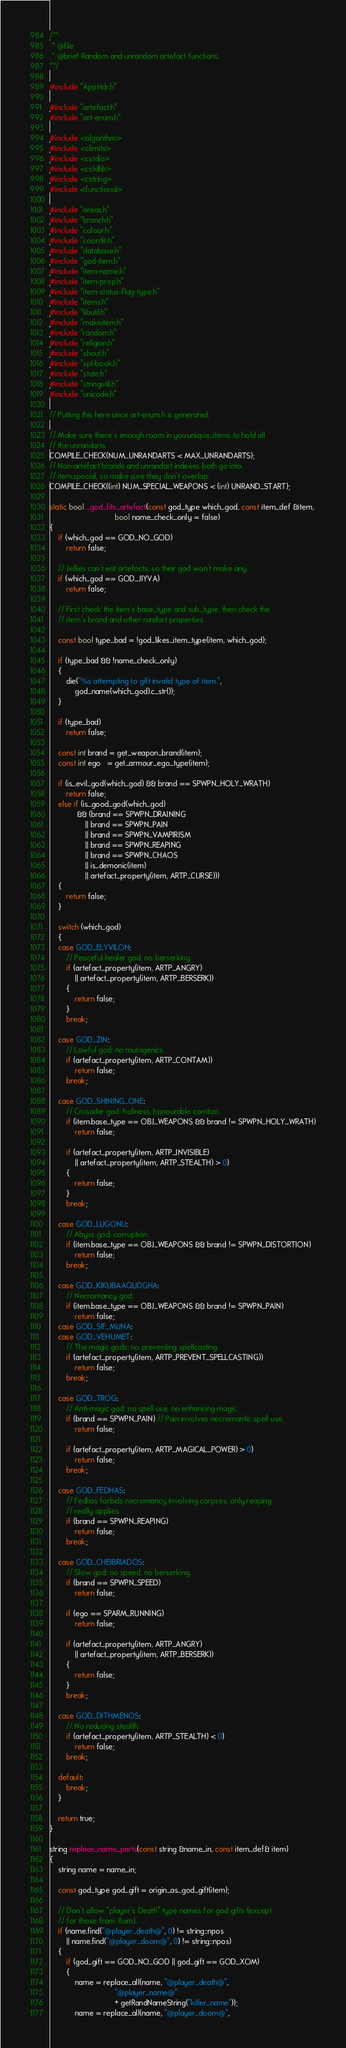Convert code to text. <code><loc_0><loc_0><loc_500><loc_500><_C++_>/**
 * @file
 * @brief Random and unrandom artefact functions.
**/

#include "AppHdr.h"

#include "artefact.h"
#include "art-enum.h"

#include <algorithm>
#include <climits>
#include <cstdio>
#include <cstdlib>
#include <cstring>
#include <functional>

#include "areas.h"
#include "branch.h"
#include "colour.h"
#include "coordit.h"
#include "database.h"
#include "god-item.h"
#include "item-name.h"
#include "item-prop.h"
#include "item-status-flag-type.h"
#include "items.h"
#include "libutil.h"
#include "makeitem.h"
#include "random.h"
#include "religion.h"
#include "shout.h"
#include "spl-book.h"
#include "state.h"
#include "stringutil.h"
#include "unicode.h"

// Putting this here since art-enum.h is generated.

// Make sure there's enough room in you.unique_items to hold all
// the unrandarts.
COMPILE_CHECK(NUM_UNRANDARTS < MAX_UNRANDARTS);
// Non-artefact brands and unrandart indexes both go into
// item.special, so make sure they don't overlap.
COMPILE_CHECK((int) NUM_SPECIAL_WEAPONS < (int) UNRAND_START);

static bool _god_fits_artefact(const god_type which_god, const item_def &item,
                               bool name_check_only = false)
{
    if (which_god == GOD_NO_GOD)
        return false;

    // Jellies can't eat artefacts, so their god won't make any.
    if (which_god == GOD_JIYVA)
        return false;

    // First check the item's base_type and sub_type, then check the
    // item's brand and other randart properties.

    const bool type_bad = !god_likes_item_type(item, which_god);

    if (type_bad && !name_check_only)
    {
        die("%s attempting to gift invalid type of item.",
            god_name(which_god).c_str());
    }

    if (type_bad)
        return false;

    const int brand = get_weapon_brand(item);
    const int ego   = get_armour_ego_type(item);

    if (is_evil_god(which_god) && brand == SPWPN_HOLY_WRATH)
        return false;
    else if (is_good_god(which_god)
             && (brand == SPWPN_DRAINING
                 || brand == SPWPN_PAIN
                 || brand == SPWPN_VAMPIRISM
                 || brand == SPWPN_REAPING
                 || brand == SPWPN_CHAOS
                 || is_demonic(item)
                 || artefact_property(item, ARTP_CURSE)))
    {
        return false;
    }

    switch (which_god)
    {
    case GOD_ELYVILON:
        // Peaceful healer god: no berserking.
        if (artefact_property(item, ARTP_ANGRY)
            || artefact_property(item, ARTP_BERSERK))
        {
            return false;
        }
        break;

    case GOD_ZIN:
        // Lawful god: no mutagenics.
        if (artefact_property(item, ARTP_CONTAM))
            return false;
        break;

    case GOD_SHINING_ONE:
        // Crusader god: holiness, honourable combat.
        if (item.base_type == OBJ_WEAPONS && brand != SPWPN_HOLY_WRATH)
            return false;

        if (artefact_property(item, ARTP_INVISIBLE)
            || artefact_property(item, ARTP_STEALTH) > 0)
        {
            return false;
        }
        break;

    case GOD_LUGONU:
        // Abyss god: corruption.
        if (item.base_type == OBJ_WEAPONS && brand != SPWPN_DISTORTION)
            return false;
        break;

    case GOD_KIKUBAAQUDGHA:
        // Necromancy god.
        if (item.base_type == OBJ_WEAPONS && brand != SPWPN_PAIN)
            return false;
    case GOD_SIF_MUNA:
    case GOD_VEHUMET:
        // The magic gods: no preventing spellcasting.
        if (artefact_property(item, ARTP_PREVENT_SPELLCASTING))
            return false;
        break;

    case GOD_TROG:
        // Anti-magic god: no spell use, no enhancing magic.
        if (brand == SPWPN_PAIN) // Pain involves necromantic spell use.
            return false;

        if (artefact_property(item, ARTP_MAGICAL_POWER) > 0)
            return false;
        break;

    case GOD_FEDHAS:
        // Fedhas forbids necromancy involving corpses, only reaping
        // really applies.
        if (brand == SPWPN_REAPING)
            return false;
        break;

    case GOD_CHEIBRIADOS:
        // Slow god: no speed, no berserking.
        if (brand == SPWPN_SPEED)
            return false;

        if (ego == SPARM_RUNNING)
            return false;

        if (artefact_property(item, ARTP_ANGRY)
            || artefact_property(item, ARTP_BERSERK))
        {
            return false;
        }
        break;

    case GOD_DITHMENOS:
        // No reducing stealth.
        if (artefact_property(item, ARTP_STEALTH) < 0)
            return false;
        break;

    default:
        break;
    }

    return true;
}

string replace_name_parts(const string &name_in, const item_def& item)
{
    string name = name_in;

    const god_type god_gift = origin_as_god_gift(item);

    // Don't allow "player's Death" type names for god gifts (except
    // for those from Xom).
    if (name.find("@player_death@", 0) != string::npos
        || name.find("@player_doom@", 0) != string::npos)
    {
        if (god_gift == GOD_NO_GOD || god_gift == GOD_XOM)
        {
            name = replace_all(name, "@player_death@",
                               "@player_name@"
                               + getRandNameString("killer_name"));
            name = replace_all(name, "@player_doom@",</code> 